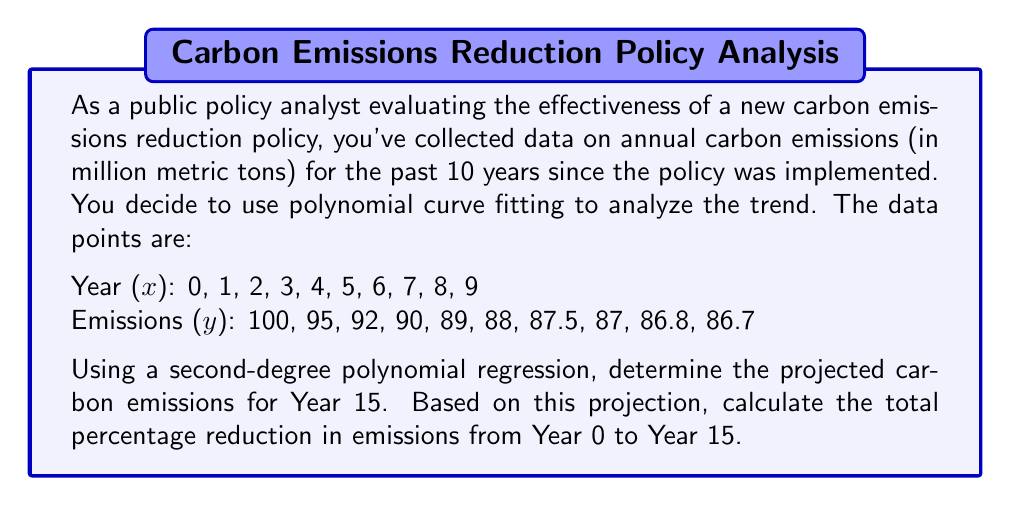Could you help me with this problem? To solve this problem, we'll follow these steps:

1) First, we need to find the second-degree polynomial that best fits the data. The general form is:

   $$ y = ax^2 + bx + c $$

   Where $a$, $b$, and $c$ are constants we need to determine.

2) Using a polynomial regression calculator or software (like Excel or Python), we can determine these constants. The resulting equation is:

   $$ y = 0.1429x^2 - 2.6071x + 99.2857 $$

3) To project the emissions for Year 15, we substitute $x = 15$ into our equation:

   $$ y = 0.1429(15)^2 - 2.6071(15) + 99.2857 $$
   $$ y = 0.1429(225) - 39.1065 + 99.2857 $$
   $$ y = 32.1525 - 39.1065 + 99.2857 $$
   $$ y = 92.3317 $$

4) Now we can calculate the percentage reduction from Year 0 to Year 15:

   Year 0 emissions: 100 million metric tons
   Year 15 projected emissions: 92.3317 million metric tons

   Reduction = 100 - 92.3317 = 7.6683 million metric tons

   Percentage reduction = $\frac{7.6683}{100} \times 100\% = 7.6683\%$

This analysis shows that while the policy has led to a reduction in emissions, the rate of decrease is slowing down over time, as indicated by the positive quadratic term in our polynomial. This suggests that more ambitious or innovative policies might be needed to maintain or accelerate the rate of emissions reduction in the future.
Answer: The projected carbon emissions for Year 15 are 92.3317 million metric tons, and the total percentage reduction in emissions from Year 0 to Year 15 is 7.6683%. 